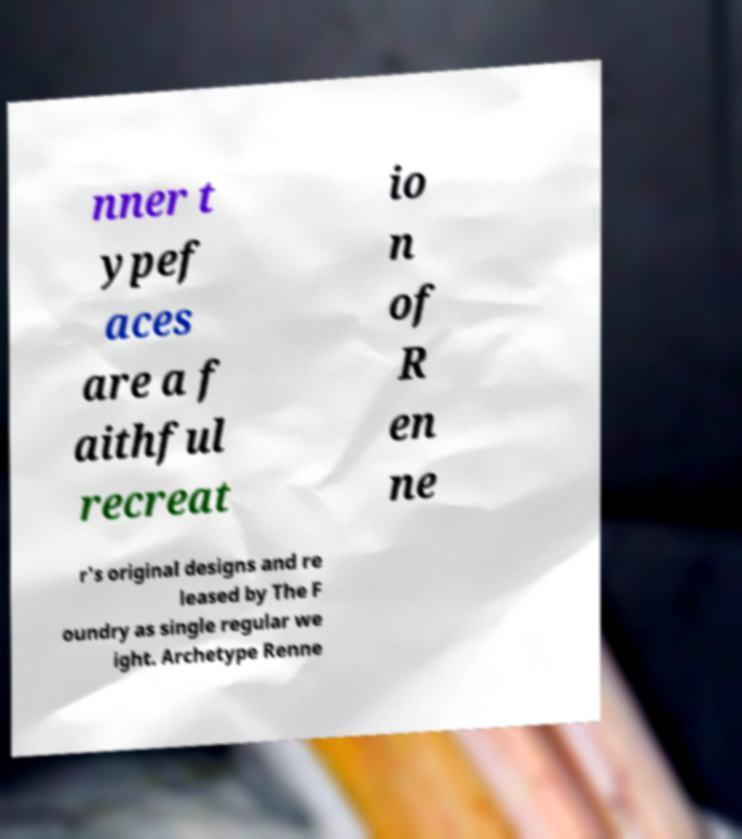For documentation purposes, I need the text within this image transcribed. Could you provide that? nner t ypef aces are a f aithful recreat io n of R en ne r's original designs and re leased by The F oundry as single regular we ight. Archetype Renne 